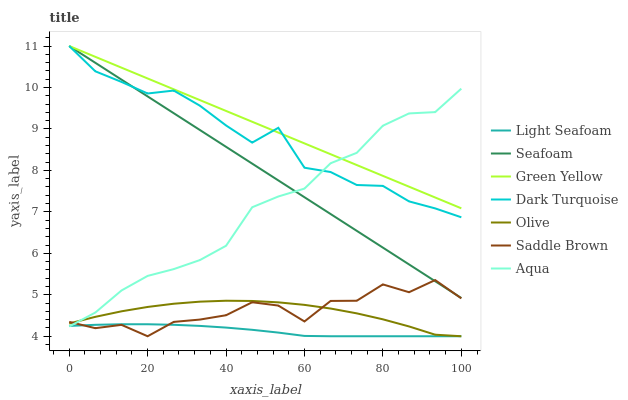Does Light Seafoam have the minimum area under the curve?
Answer yes or no. Yes. Does Green Yellow have the maximum area under the curve?
Answer yes or no. Yes. Does Dark Turquoise have the minimum area under the curve?
Answer yes or no. No. Does Dark Turquoise have the maximum area under the curve?
Answer yes or no. No. Is Green Yellow the smoothest?
Answer yes or no. Yes. Is Saddle Brown the roughest?
Answer yes or no. Yes. Is Dark Turquoise the smoothest?
Answer yes or no. No. Is Dark Turquoise the roughest?
Answer yes or no. No. Does Light Seafoam have the lowest value?
Answer yes or no. Yes. Does Dark Turquoise have the lowest value?
Answer yes or no. No. Does Green Yellow have the highest value?
Answer yes or no. Yes. Does Aqua have the highest value?
Answer yes or no. No. Is Saddle Brown less than Green Yellow?
Answer yes or no. Yes. Is Green Yellow greater than Light Seafoam?
Answer yes or no. Yes. Does Aqua intersect Saddle Brown?
Answer yes or no. Yes. Is Aqua less than Saddle Brown?
Answer yes or no. No. Is Aqua greater than Saddle Brown?
Answer yes or no. No. Does Saddle Brown intersect Green Yellow?
Answer yes or no. No. 